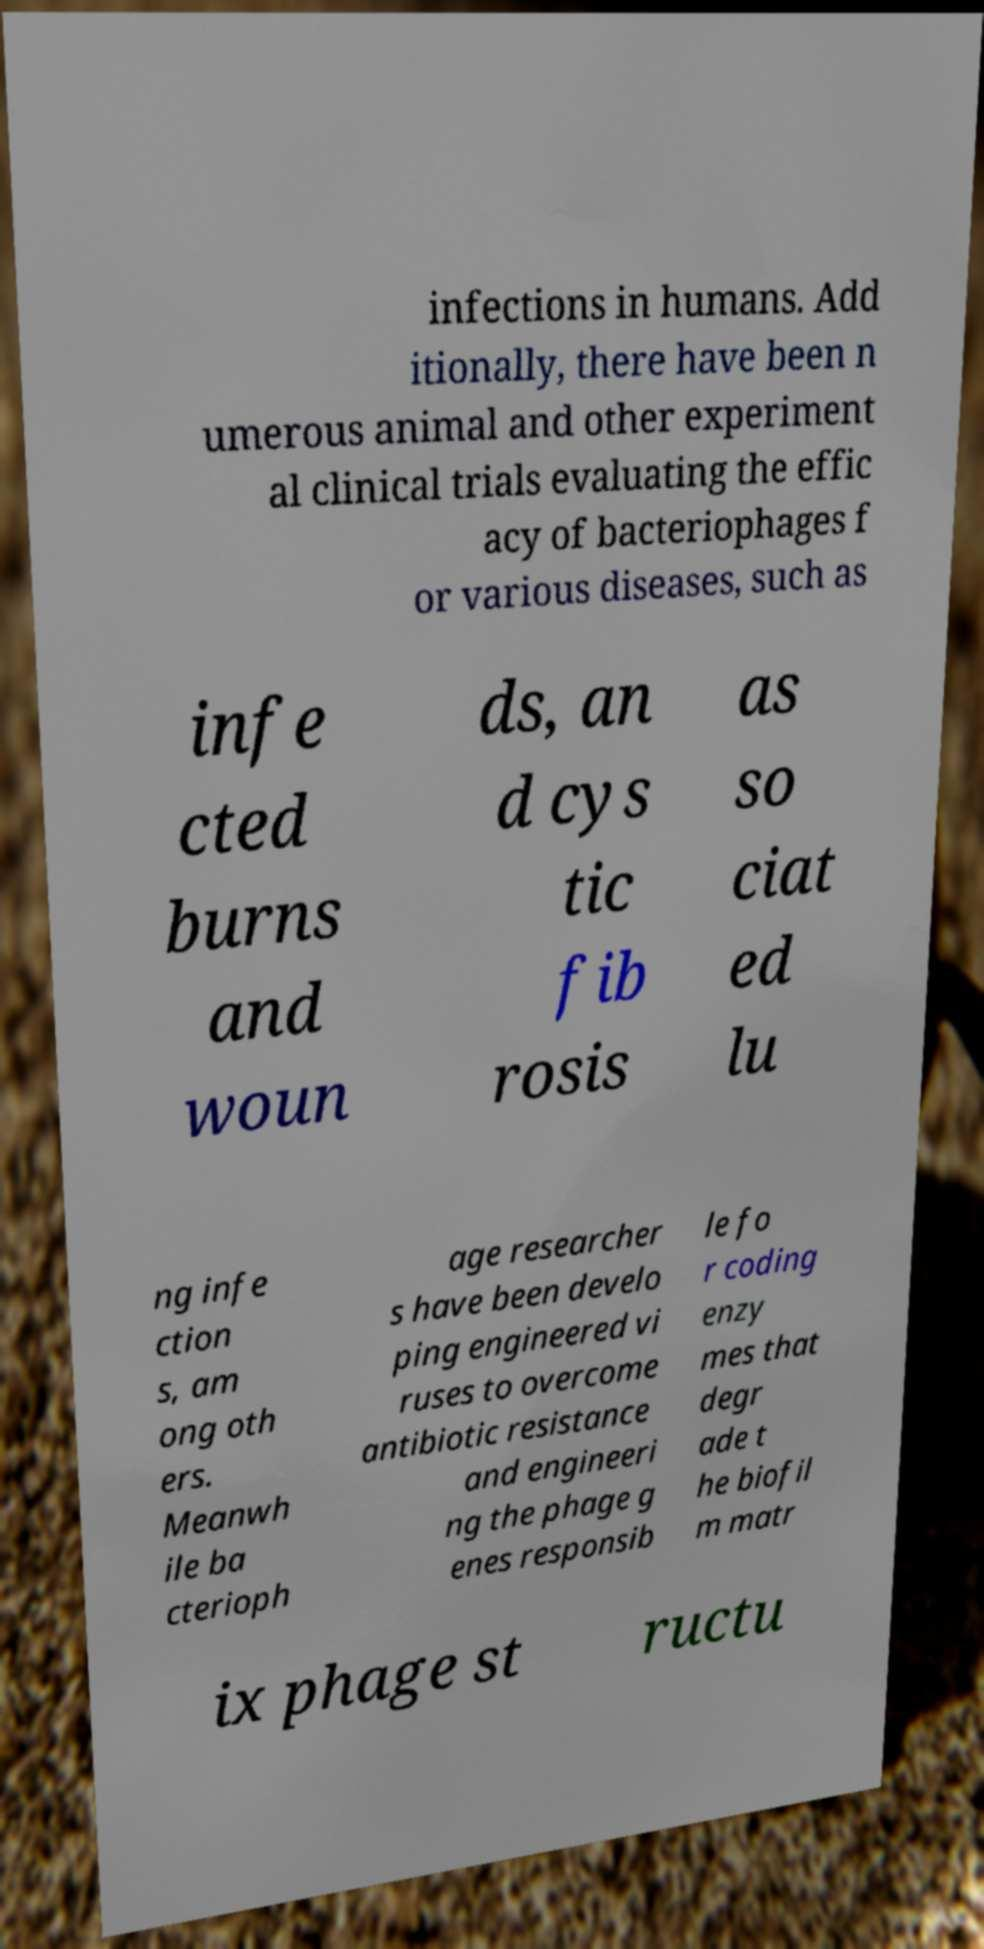Can you read and provide the text displayed in the image?This photo seems to have some interesting text. Can you extract and type it out for me? infections in humans. Add itionally, there have been n umerous animal and other experiment al clinical trials evaluating the effic acy of bacteriophages f or various diseases, such as infe cted burns and woun ds, an d cys tic fib rosis as so ciat ed lu ng infe ction s, am ong oth ers. Meanwh ile ba cterioph age researcher s have been develo ping engineered vi ruses to overcome antibiotic resistance and engineeri ng the phage g enes responsib le fo r coding enzy mes that degr ade t he biofil m matr ix phage st ructu 